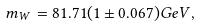Convert formula to latex. <formula><loc_0><loc_0><loc_500><loc_500>m _ { W } = 8 1 . 7 1 ( 1 \pm 0 . 0 6 7 ) G e V ,</formula> 